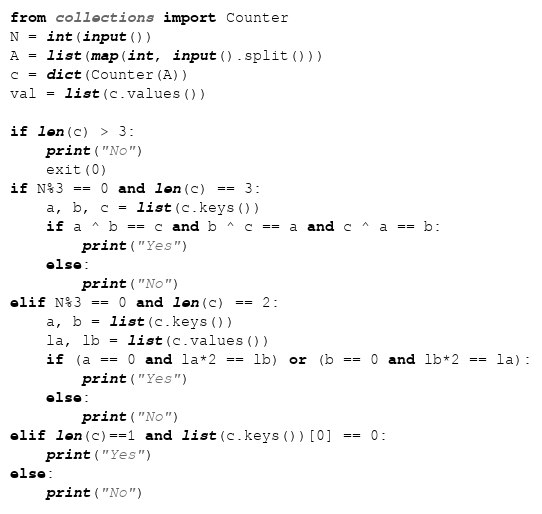Convert code to text. <code><loc_0><loc_0><loc_500><loc_500><_Python_>from collections import Counter
N = int(input())
A = list(map(int, input().split()))
c = dict(Counter(A))
val = list(c.values())

if len(c) > 3:
    print("No")
    exit(0)
if N%3 == 0 and len(c) == 3:
    a, b, c = list(c.keys())
    if a ^ b == c and b ^ c == a and c ^ a == b:
        print("Yes")
    else:
        print("No")
elif N%3 == 0 and len(c) == 2:
    a, b = list(c.keys())
    la, lb = list(c.values())
    if (a == 0 and la*2 == lb) or (b == 0 and lb*2 == la):
        print("Yes")
    else:
        print("No")
elif len(c)==1 and list(c.keys())[0] == 0:
    print("Yes")
else:
    print("No")
</code> 